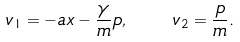<formula> <loc_0><loc_0><loc_500><loc_500>v _ { 1 } = - a x - \frac { \gamma } { m } p , \quad v _ { 2 } = \frac { p } { m } .</formula> 